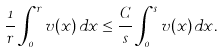Convert formula to latex. <formula><loc_0><loc_0><loc_500><loc_500>\frac { 1 } { r } \int _ { 0 } ^ { r } v ( x ) \, d x \leq \frac { C } { s } \int _ { 0 } ^ { s } v ( x ) \, d x .</formula> 